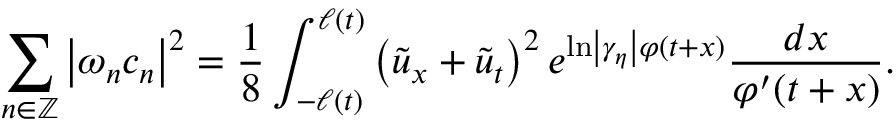Convert formula to latex. <formula><loc_0><loc_0><loc_500><loc_500>\sum _ { n \in \mathbb { Z } } \left | \omega _ { n } c _ { n } \right | ^ { 2 } = \frac { 1 } { 8 } \int _ { - \ell \left ( t \right ) } ^ { \ell \left ( t \right ) } \left ( \tilde { u } _ { x } + \tilde { u } _ { t } \right ) ^ { 2 } e ^ { \ln \left | \gamma _ { \eta } \right | \varphi ( t + x ) } \frac { d x } { \varphi ^ { \prime } ( t + x ) } .</formula> 